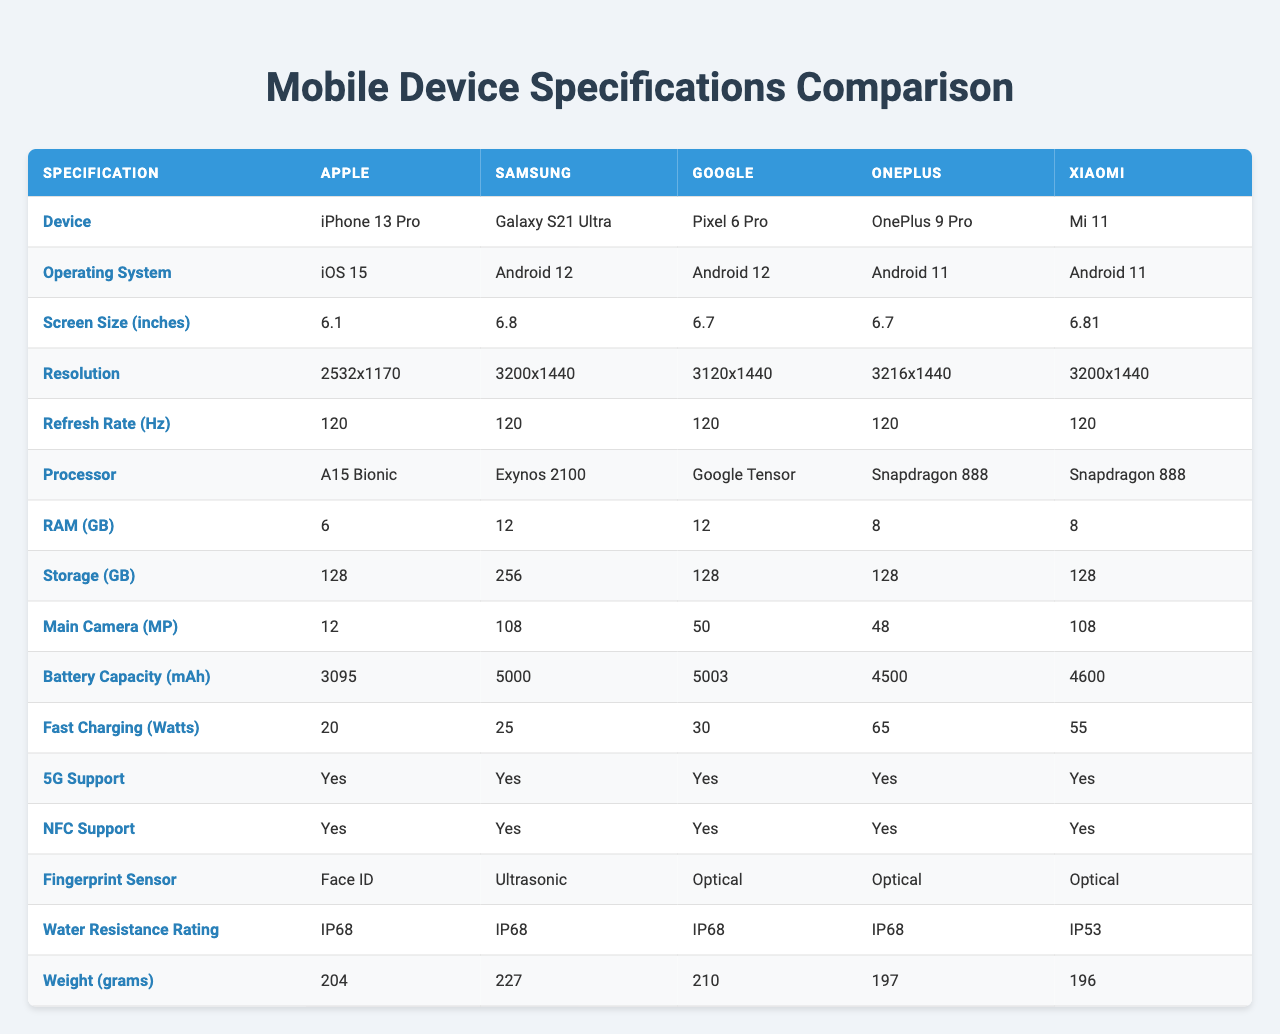What is the screen size of the Galaxy S21 Ultra? The table lists the screen sizes of each device. For the Galaxy S21 Ultra, the screen size is stated as 6.8 inches.
Answer: 6.8 inches Which device has the highest main camera resolution? By comparing the main camera resolutions listed in the table, the Galaxy S21 Ultra has a resolution of 108 MP, which is the highest among the devices.
Answer: Galaxy S21 Ultra What operating system does the Pixel 6 Pro use? The operating system row in the table reveals that the Pixel 6 Pro operates on Android 12.
Answer: Android 12 Do all devices support 5G? The 5G support row shows 'true' for all devices; thus, they support 5G.
Answer: Yes What is the difference in battery capacity between the iPhone 13 Pro and the OnePlus 9 Pro? The iPhone 13 Pro has a battery capacity of 3095 mAh and the OnePlus 9 Pro has 4500 mAh, resulting in a difference of 4500 - 3095 = 1405 mAh.
Answer: 1405 mAh What is the average RAM size of the devices listed? The total amount of RAM for each device is 6 + 12 + 12 + 8 + 8 = 46 GB. Since there are 5 devices, the average RAM size is 46 / 5 = 9.2 GB.
Answer: 9.2 GB Which device has the lowest weight? By looking at the weight row, the OnePlus 9 Pro weighs 197 grams, which is the lowest weight when compared to the other devices.
Answer: OnePlus 9 Pro Is the Mi 11 water-resistant? The water resistance rating for the Mi 11 is IP53, which indicates it is not fully water-resistant like others rated IP68.
Answer: No How many devices have 12 GB of RAM? Checking the RAM sizes, both the Galaxy S21 Ultra and Pixel 6 Pro have 12 GB of RAM, which totals to two devices.
Answer: 2 What is the average battery capacity for the devices that run on Android? The devices running Android are the Galaxy S21 Ultra, Pixel 6 Pro, OnePlus 9 Pro, and Mi 11. Their battery capacities are 5000, 5003, 4500, and 4600 mAh respectively, summing up to 5000 + 5003 + 4500 + 4600 = 19103 mAh. The average is then 19103 / 4 = 4775.75 mAh.
Answer: 4775.75 mAh 